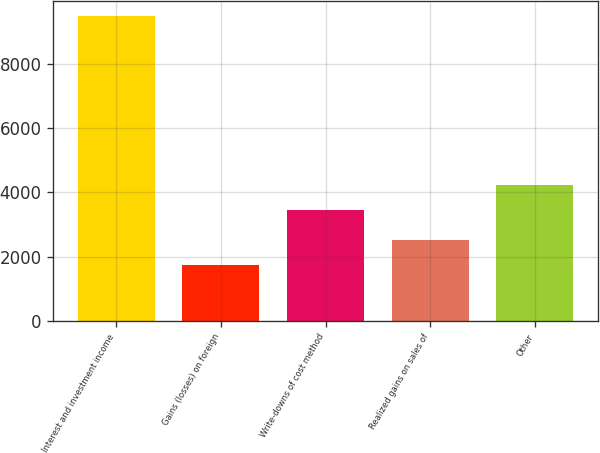<chart> <loc_0><loc_0><loc_500><loc_500><bar_chart><fcel>Interest and investment income<fcel>Gains (losses) on foreign<fcel>Write-downs of cost method<fcel>Realized gains on sales of<fcel>Other<nl><fcel>9466<fcel>1727<fcel>3436<fcel>2500.9<fcel>4209.9<nl></chart> 